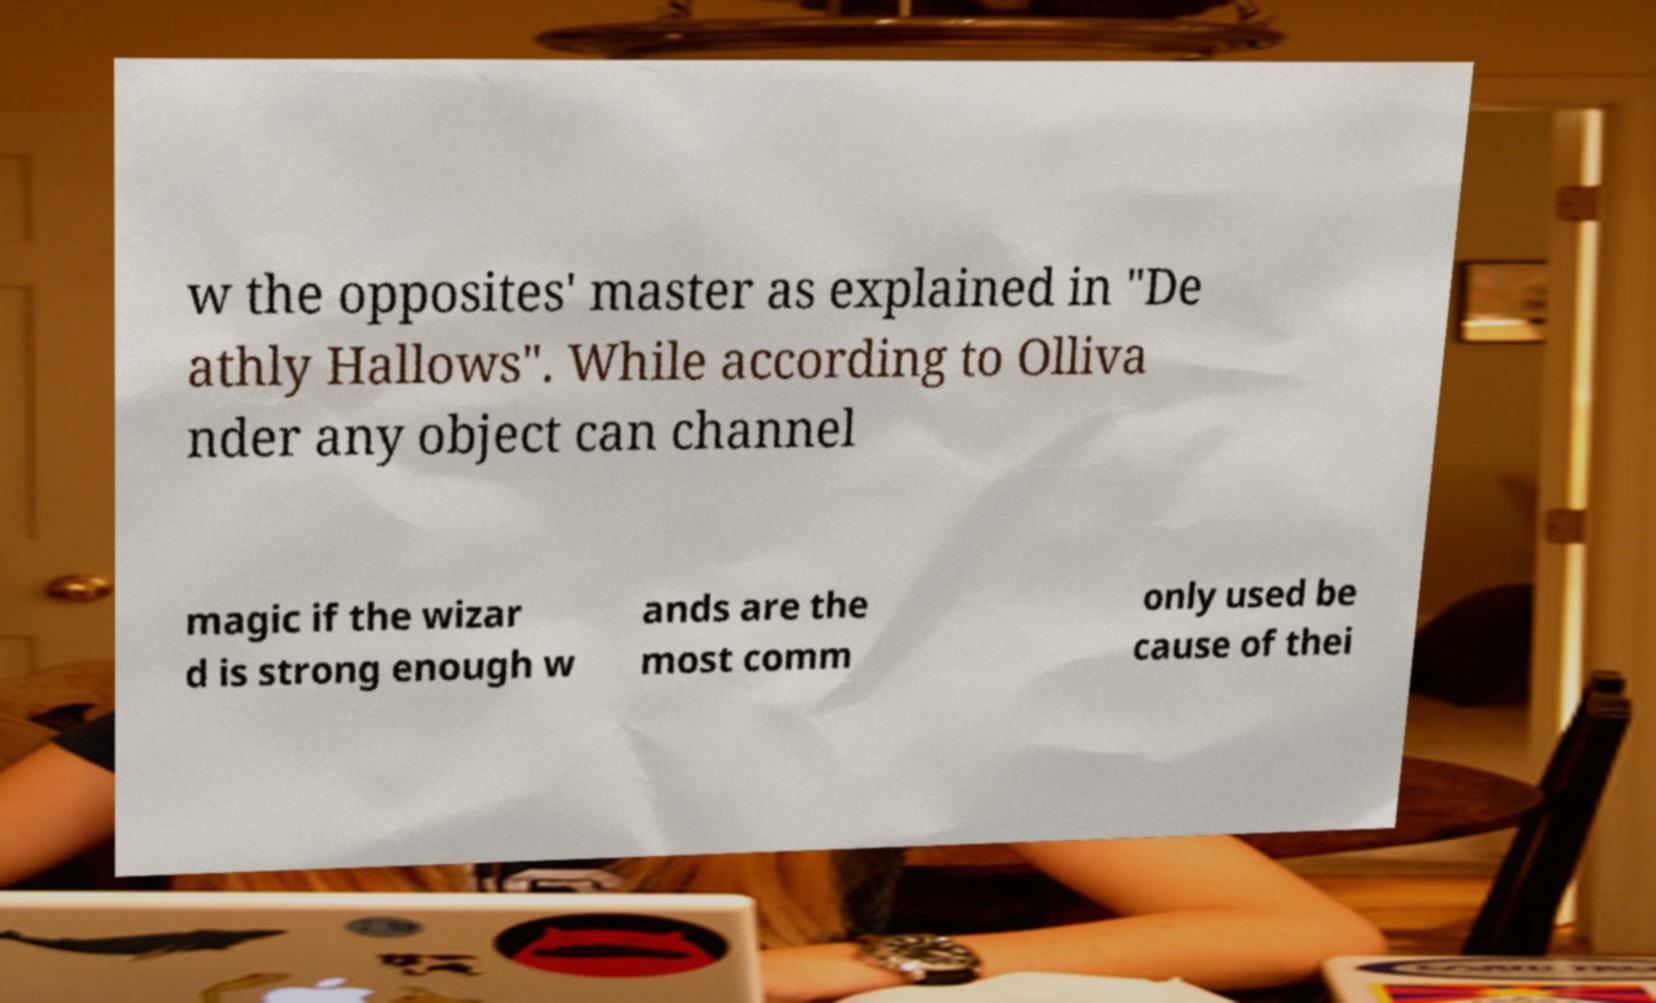For documentation purposes, I need the text within this image transcribed. Could you provide that? w the opposites' master as explained in "De athly Hallows". While according to Olliva nder any object can channel magic if the wizar d is strong enough w ands are the most comm only used be cause of thei 